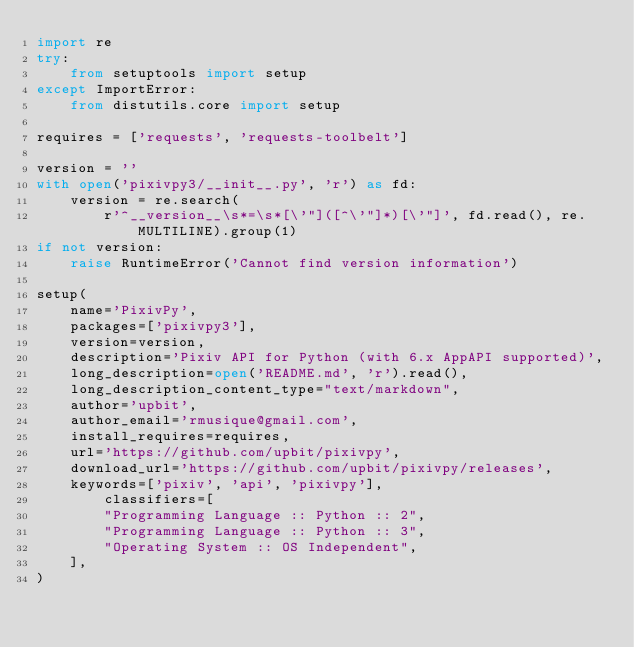Convert code to text. <code><loc_0><loc_0><loc_500><loc_500><_Python_>import re
try:
    from setuptools import setup
except ImportError:
    from distutils.core import setup

requires = ['requests', 'requests-toolbelt']

version = ''
with open('pixivpy3/__init__.py', 'r') as fd:
    version = re.search(
        r'^__version__\s*=\s*[\'"]([^\'"]*)[\'"]', fd.read(), re.MULTILINE).group(1)
if not version:
    raise RuntimeError('Cannot find version information')

setup(
    name='PixivPy',
    packages=['pixivpy3'],
    version=version,
    description='Pixiv API for Python (with 6.x AppAPI supported)',
    long_description=open('README.md', 'r').read(),
    long_description_content_type="text/markdown",
    author='upbit',
    author_email='rmusique@gmail.com',
    install_requires=requires,
    url='https://github.com/upbit/pixivpy',
    download_url='https://github.com/upbit/pixivpy/releases',
    keywords=['pixiv', 'api', 'pixivpy'],
        classifiers=[
        "Programming Language :: Python :: 2",
        "Programming Language :: Python :: 3",
        "Operating System :: OS Independent",
    ],
)
</code> 